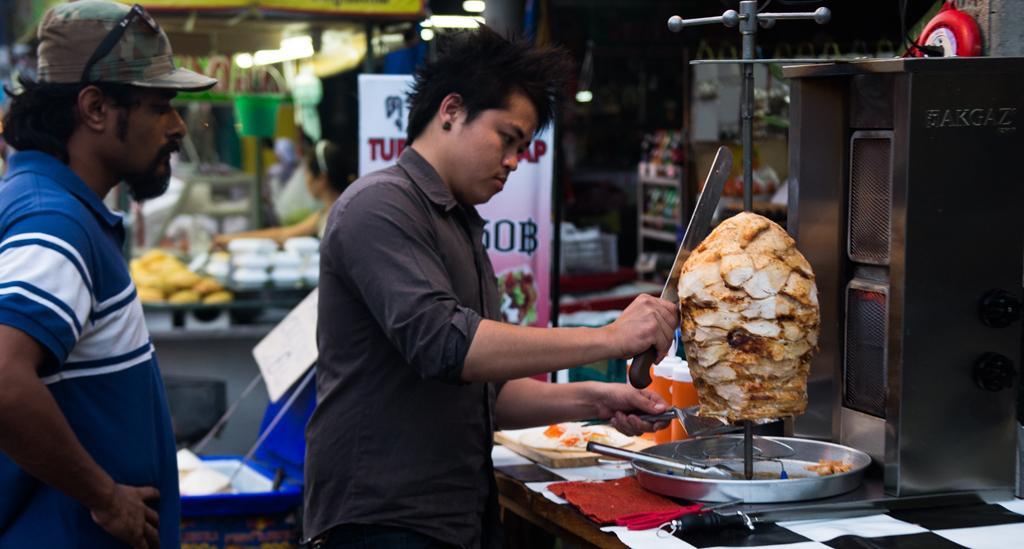How would you summarize this image in a sentence or two? In the picture I can see two people, around we can see so many things. 